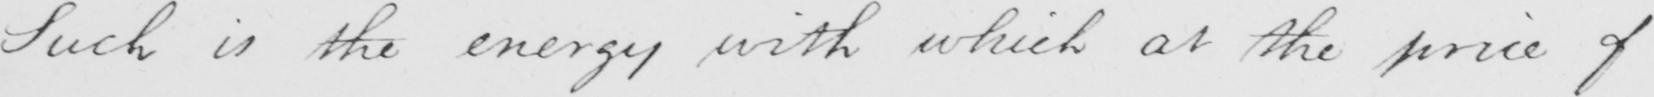Can you read and transcribe this handwriting? Such is the energy with which at the price of 